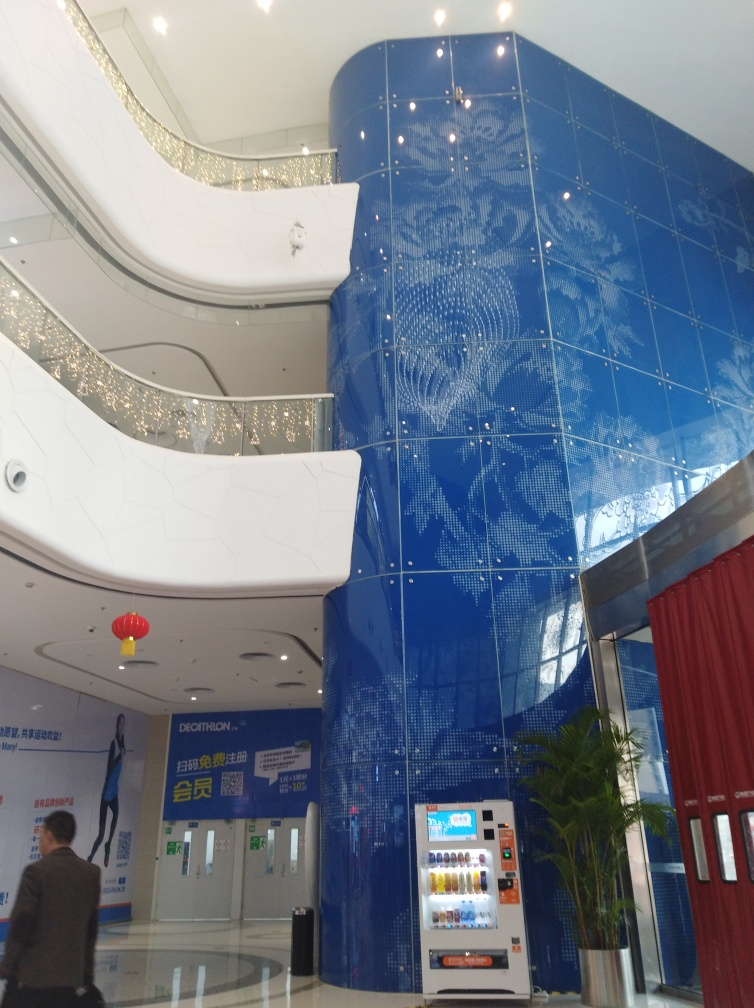Are there any unique features in the interior that stand out besides the blue wall? Beyond the striking blue mosaic wall, the interior features a blend of curved and straight lines that define the space, creating an interplay between sleek modernity and soft fluidity. The bright white walls contrast strikingly with the blue, and the use of embedded lights in the ceilings contributes to a starry ambiance. Additionally, the presence of a vending machine suggests the space is designed to cater to public convenience, indicating functionality alongside aesthetic considerations. 